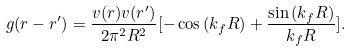<formula> <loc_0><loc_0><loc_500><loc_500>g ( { r } - { r } ^ { \prime } ) = \frac { v ( { r } ) v ( { r } ^ { \prime } ) } { 2 \pi ^ { 2 } R ^ { 2 } } [ - \cos { ( k _ { f } R ) } + \frac { \sin { ( k _ { f } R ) } } { k _ { f } R } ] .</formula> 